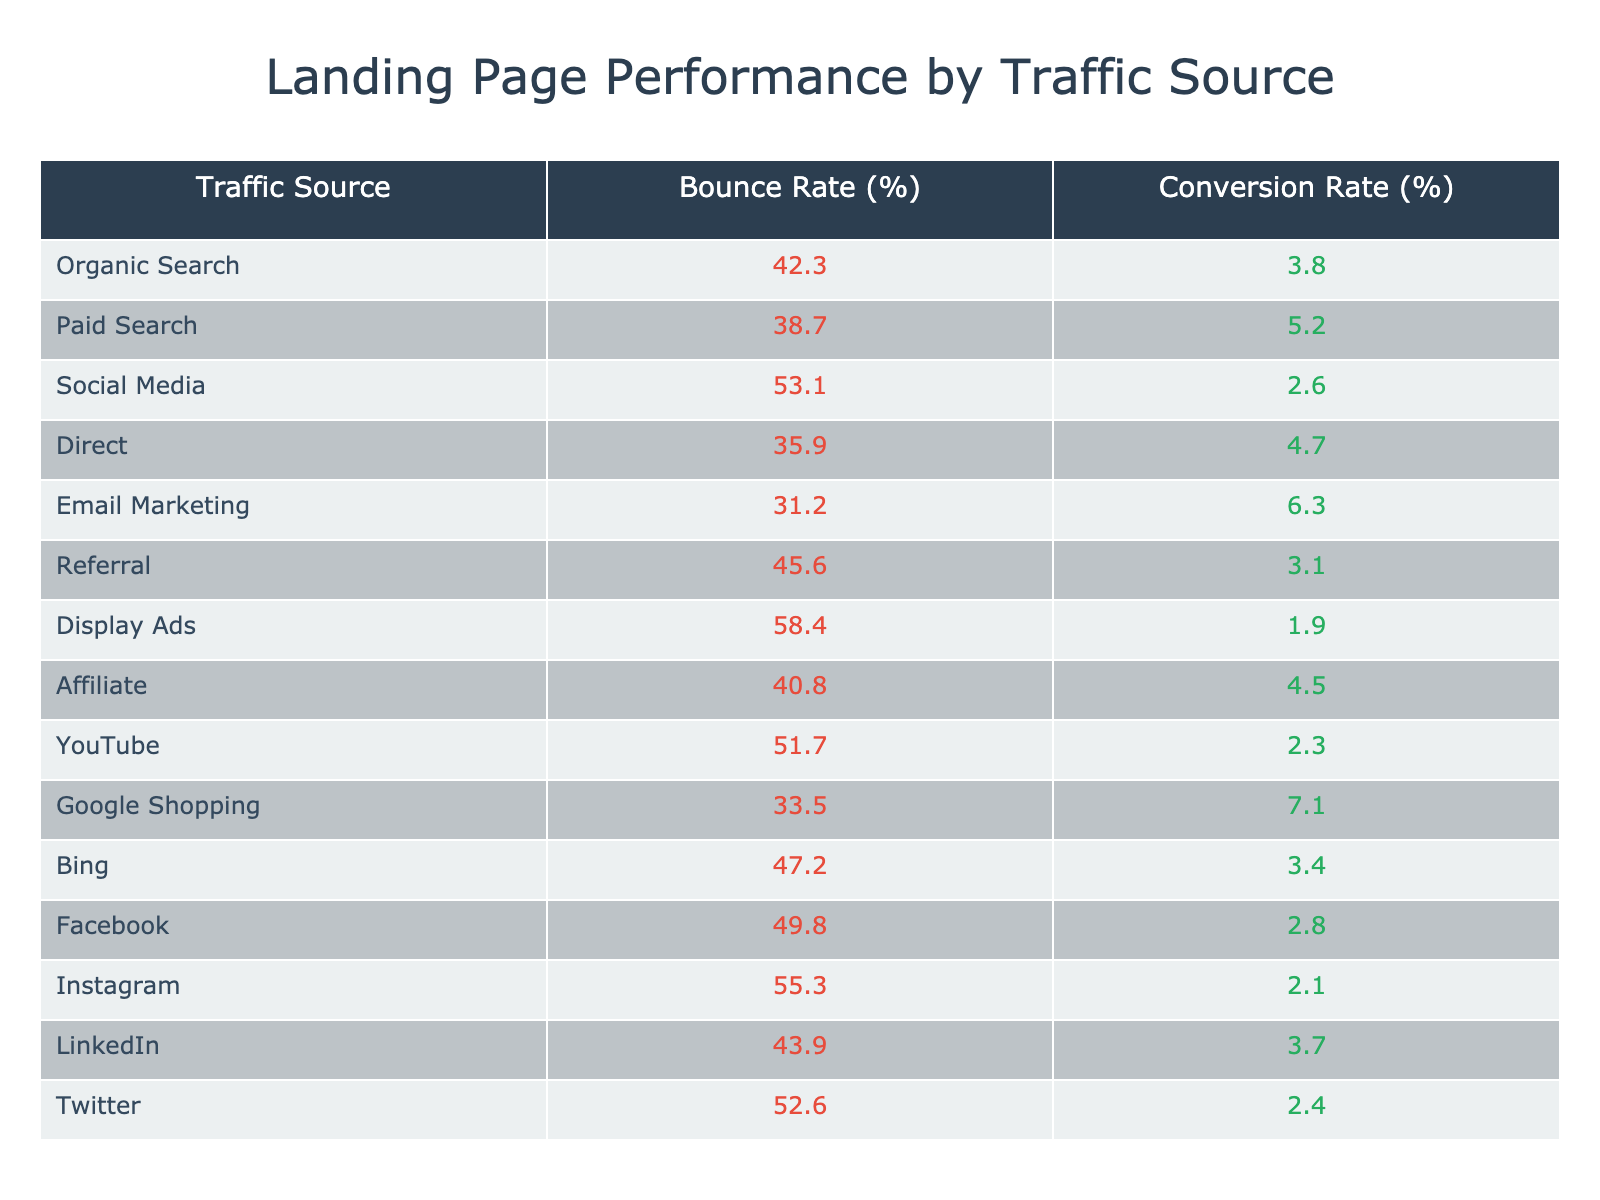What is the bounce rate for organic search? The bounce rate for organic search is directly listed in the table under the "Bounce Rate (%)" column next to "Organic Search," which shows 42.3%.
Answer: 42.3% Which traffic source has the highest conversion rate? To find the highest conversion rate, I scan the "Conversion Rate (%)" column to identify the highest number. The highest value is 7.1%, corresponding to "Google Shopping."
Answer: Google Shopping What is the average bounce rate across all traffic sources? First, I sum the bounce rates: (42.3 + 38.7 + 53.1 + 35.9 + 31.2 + 45.6 + 58.4 + 40.8 + 51.7 + 33.5 + 47.2 + 49.8 + 55.3 + 43.9 + 52.6) = 749.5. There are 15 traffic sources, so the average is 749.5 / 15 = 49.97%.
Answer: 49.97% Is the conversion rate for display ads higher than that for social media? The conversion rate for display ads is 1.9%, while for social media it is 2.6%. Since 1.9% is less than 2.6%, the conversion rate for display ads is not higher.
Answer: No How does the bounce rate of email marketing compare to that of paid search? The bounce rate for email marketing is 31.2%, and for paid search, it is 38.7%. Since 31.2% is less than 38.7%, email marketing has a lower bounce rate than paid search.
Answer: Lower What is the difference in conversion rates between Google Shopping and Email Marketing? The conversion rate for Google Shopping is 7.1% and for Email Marketing is 6.3%. The difference is calculated by subtracting 6.3% from 7.1%, giving 7.1% - 6.3% = 0.8%.
Answer: 0.8% Are the bounce rates for social media and referral traffic sources both above 45%? The bounce rate for social media is 53.1%, and for referral traffic, it is 45.6%. Both percentages are above 45%, so the statement is true.
Answer: Yes Which traffic source has both a bounce rate and conversion rate below the averages? The average bounce rate is approximately 49.97%, and the average conversion rate can be calculated as well. After reviewing the data, "Email Marketing" with a bounce rate of 31.2% and conversion rate of 6.3% shows both metrics are below the respective averages.
Answer: Email Marketing What is the percentage of traffic sources with a bounce rate over 50%? There are 4 traffic sources with a bounce rate over 50% (Social Media, Display Ads, Instagram, and Twitter) out of a total of 15 sources. The percentage is calculated as (4 / 15) * 100 = 26.67%.
Answer: 26.67% 